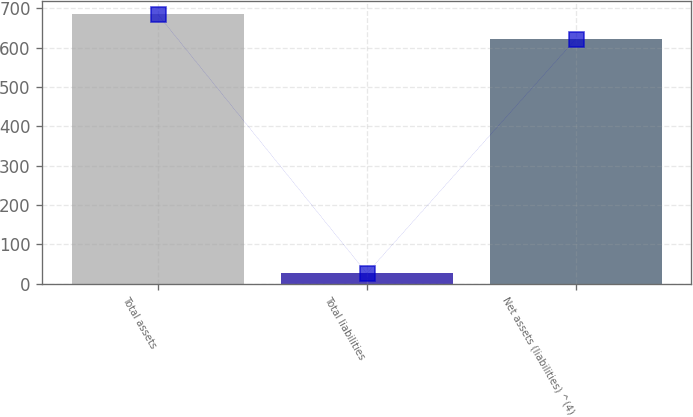Convert chart to OTSL. <chart><loc_0><loc_0><loc_500><loc_500><bar_chart><fcel>Total assets<fcel>Total liabilities<fcel>Net assets (liabilities) ^(4)<nl><fcel>684.2<fcel>26<fcel>622<nl></chart> 